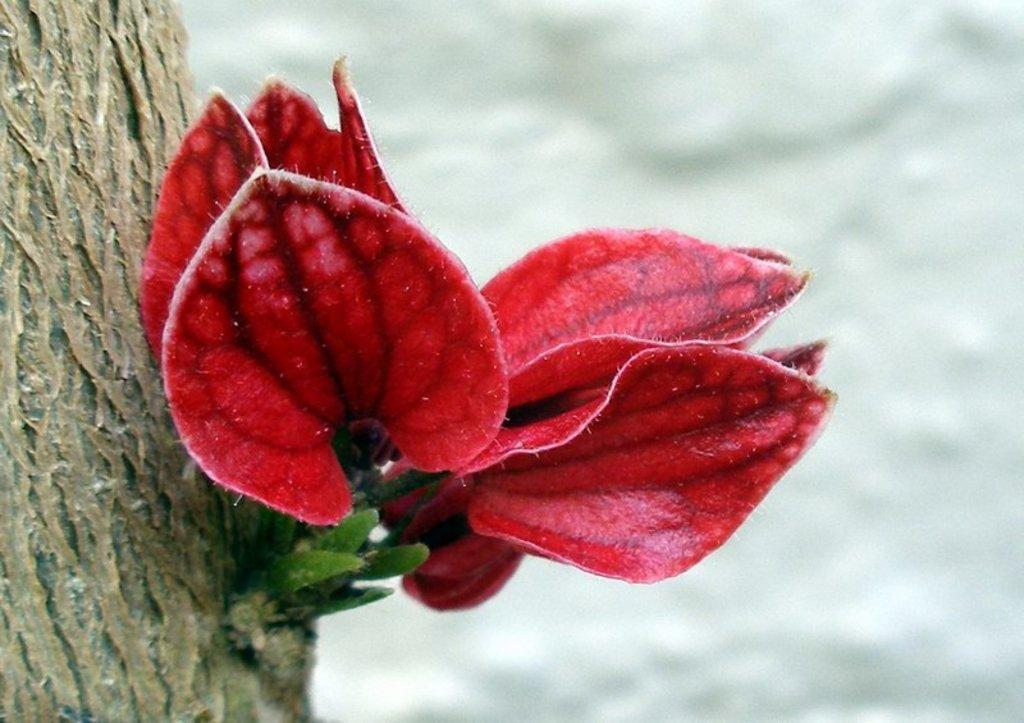In one or two sentences, can you explain what this image depicts? As we can see in the image there is a tree stem and red color leaves. The background is blurred. 